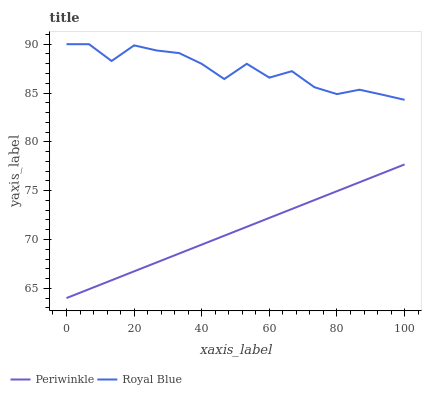Does Periwinkle have the minimum area under the curve?
Answer yes or no. Yes. Does Royal Blue have the maximum area under the curve?
Answer yes or no. Yes. Does Periwinkle have the maximum area under the curve?
Answer yes or no. No. Is Periwinkle the smoothest?
Answer yes or no. Yes. Is Royal Blue the roughest?
Answer yes or no. Yes. Is Periwinkle the roughest?
Answer yes or no. No. Does Periwinkle have the lowest value?
Answer yes or no. Yes. Does Royal Blue have the highest value?
Answer yes or no. Yes. Does Periwinkle have the highest value?
Answer yes or no. No. Is Periwinkle less than Royal Blue?
Answer yes or no. Yes. Is Royal Blue greater than Periwinkle?
Answer yes or no. Yes. Does Periwinkle intersect Royal Blue?
Answer yes or no. No. 